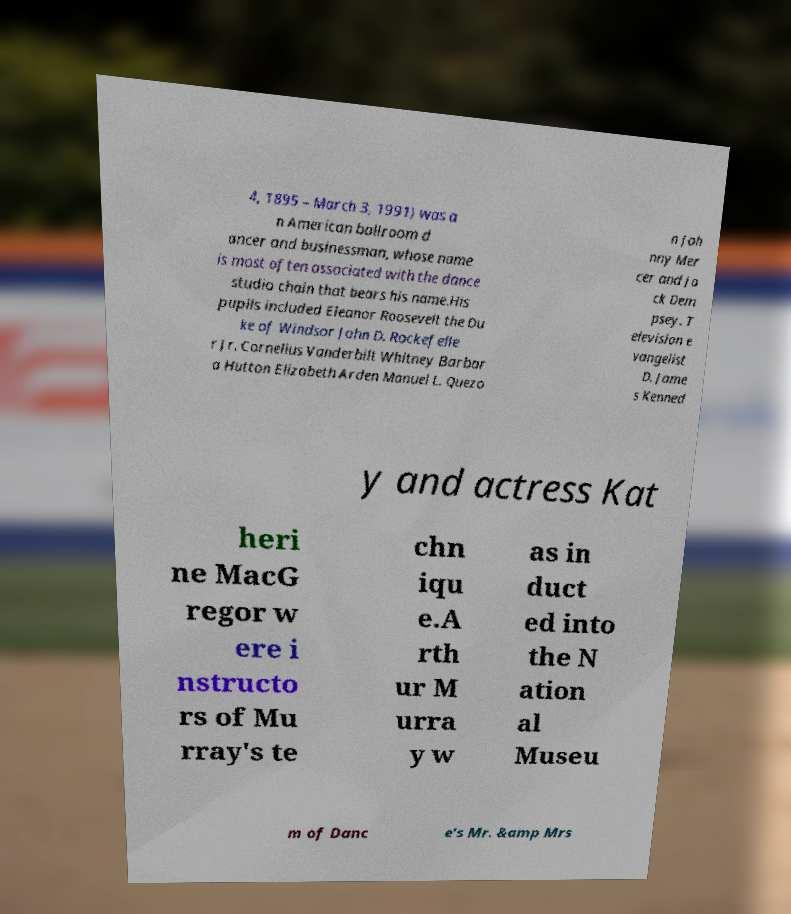Can you accurately transcribe the text from the provided image for me? 4, 1895 – March 3, 1991) was a n American ballroom d ancer and businessman, whose name is most often associated with the dance studio chain that bears his name.His pupils included Eleanor Roosevelt the Du ke of Windsor John D. Rockefelle r Jr. Cornelius Vanderbilt Whitney Barbar a Hutton Elizabeth Arden Manuel L. Quezo n Joh nny Mer cer and Ja ck Dem psey. T elevision e vangelist D. Jame s Kenned y and actress Kat heri ne MacG regor w ere i nstructo rs of Mu rray's te chn iqu e.A rth ur M urra y w as in duct ed into the N ation al Museu m of Danc e's Mr. &amp Mrs 